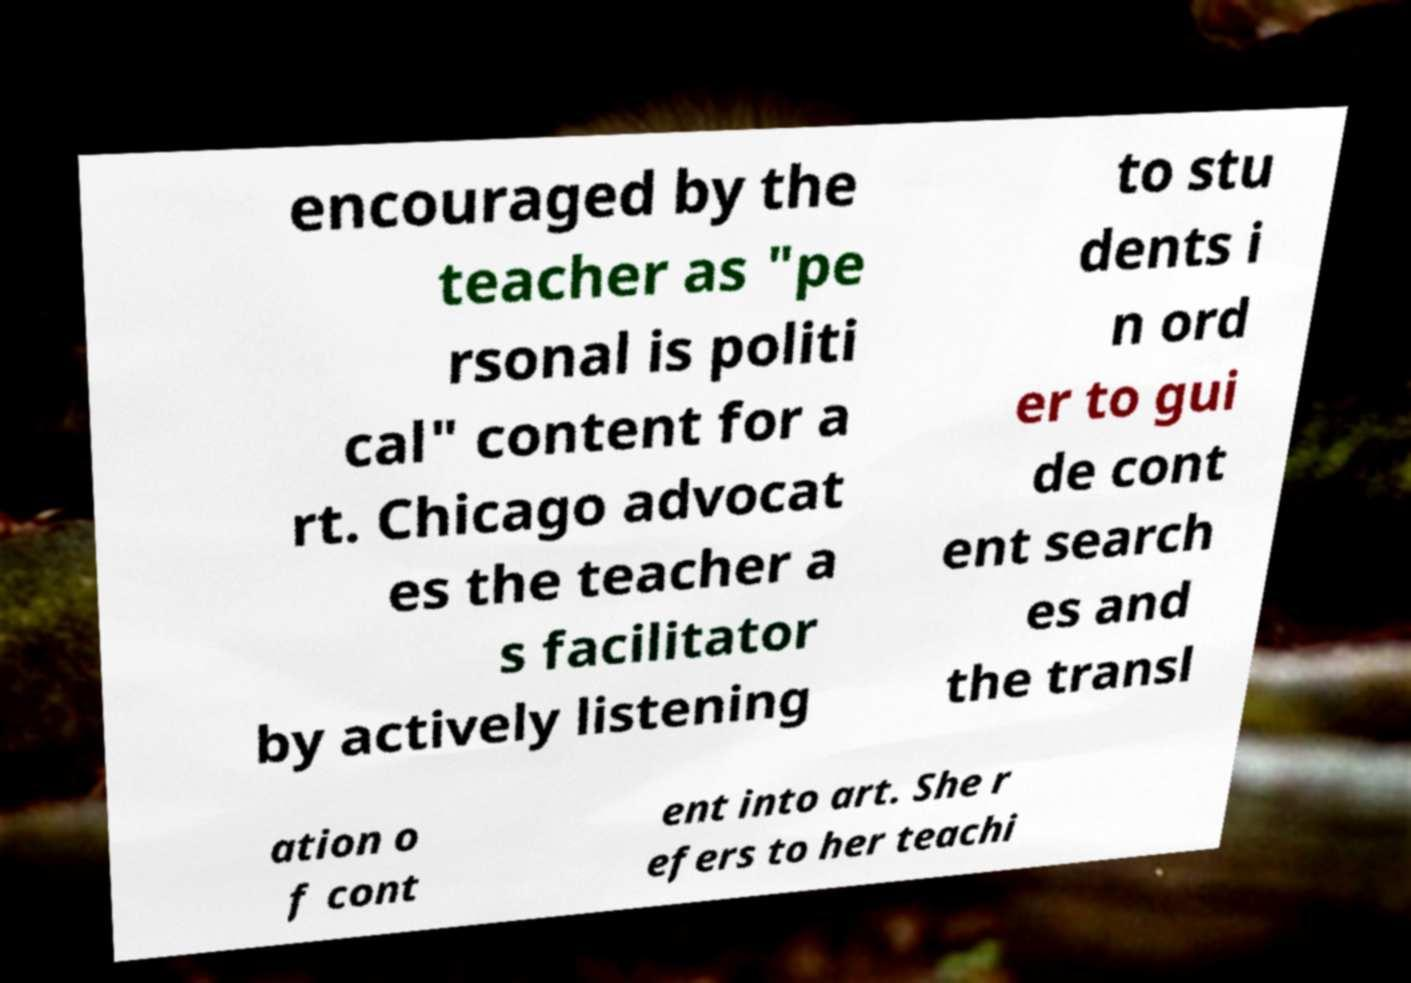Please read and relay the text visible in this image. What does it say? encouraged by the teacher as "pe rsonal is politi cal" content for a rt. Chicago advocat es the teacher a s facilitator by actively listening to stu dents i n ord er to gui de cont ent search es and the transl ation o f cont ent into art. She r efers to her teachi 